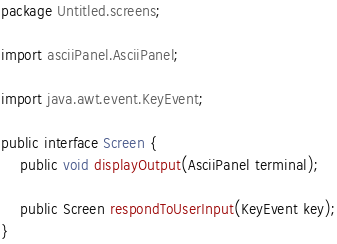Convert code to text. <code><loc_0><loc_0><loc_500><loc_500><_Java_>package Untitled.screens;

import asciiPanel.AsciiPanel;

import java.awt.event.KeyEvent;

public interface Screen {
    public void displayOutput(AsciiPanel terminal);

    public Screen respondToUserInput(KeyEvent key);
}
</code> 